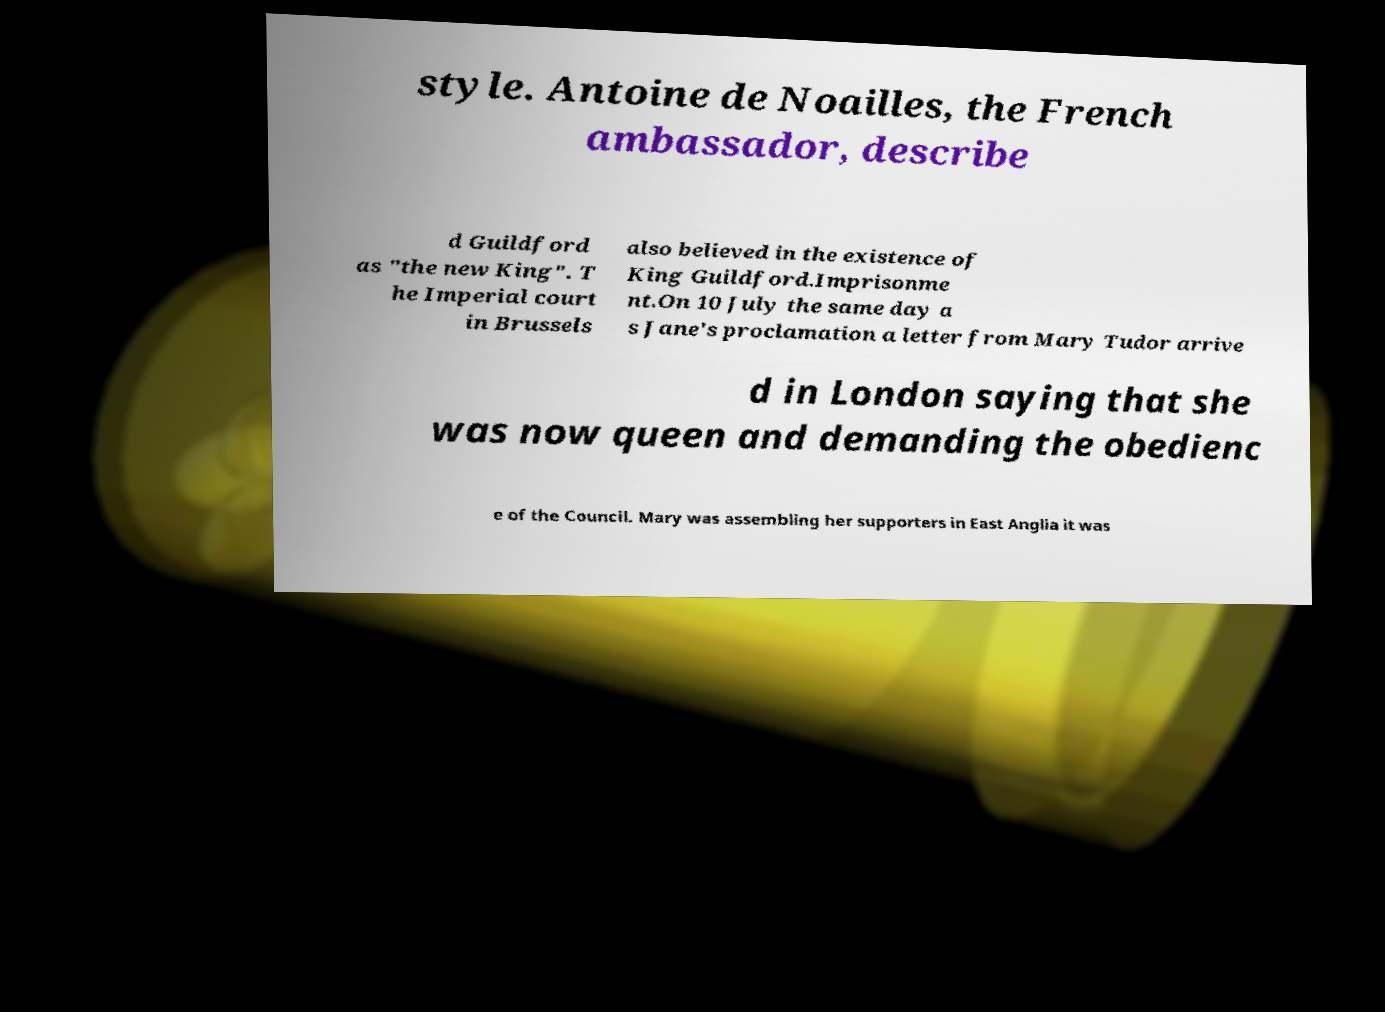There's text embedded in this image that I need extracted. Can you transcribe it verbatim? style. Antoine de Noailles, the French ambassador, describe d Guildford as "the new King". T he Imperial court in Brussels also believed in the existence of King Guildford.Imprisonme nt.On 10 July the same day a s Jane's proclamation a letter from Mary Tudor arrive d in London saying that she was now queen and demanding the obedienc e of the Council. Mary was assembling her supporters in East Anglia it was 